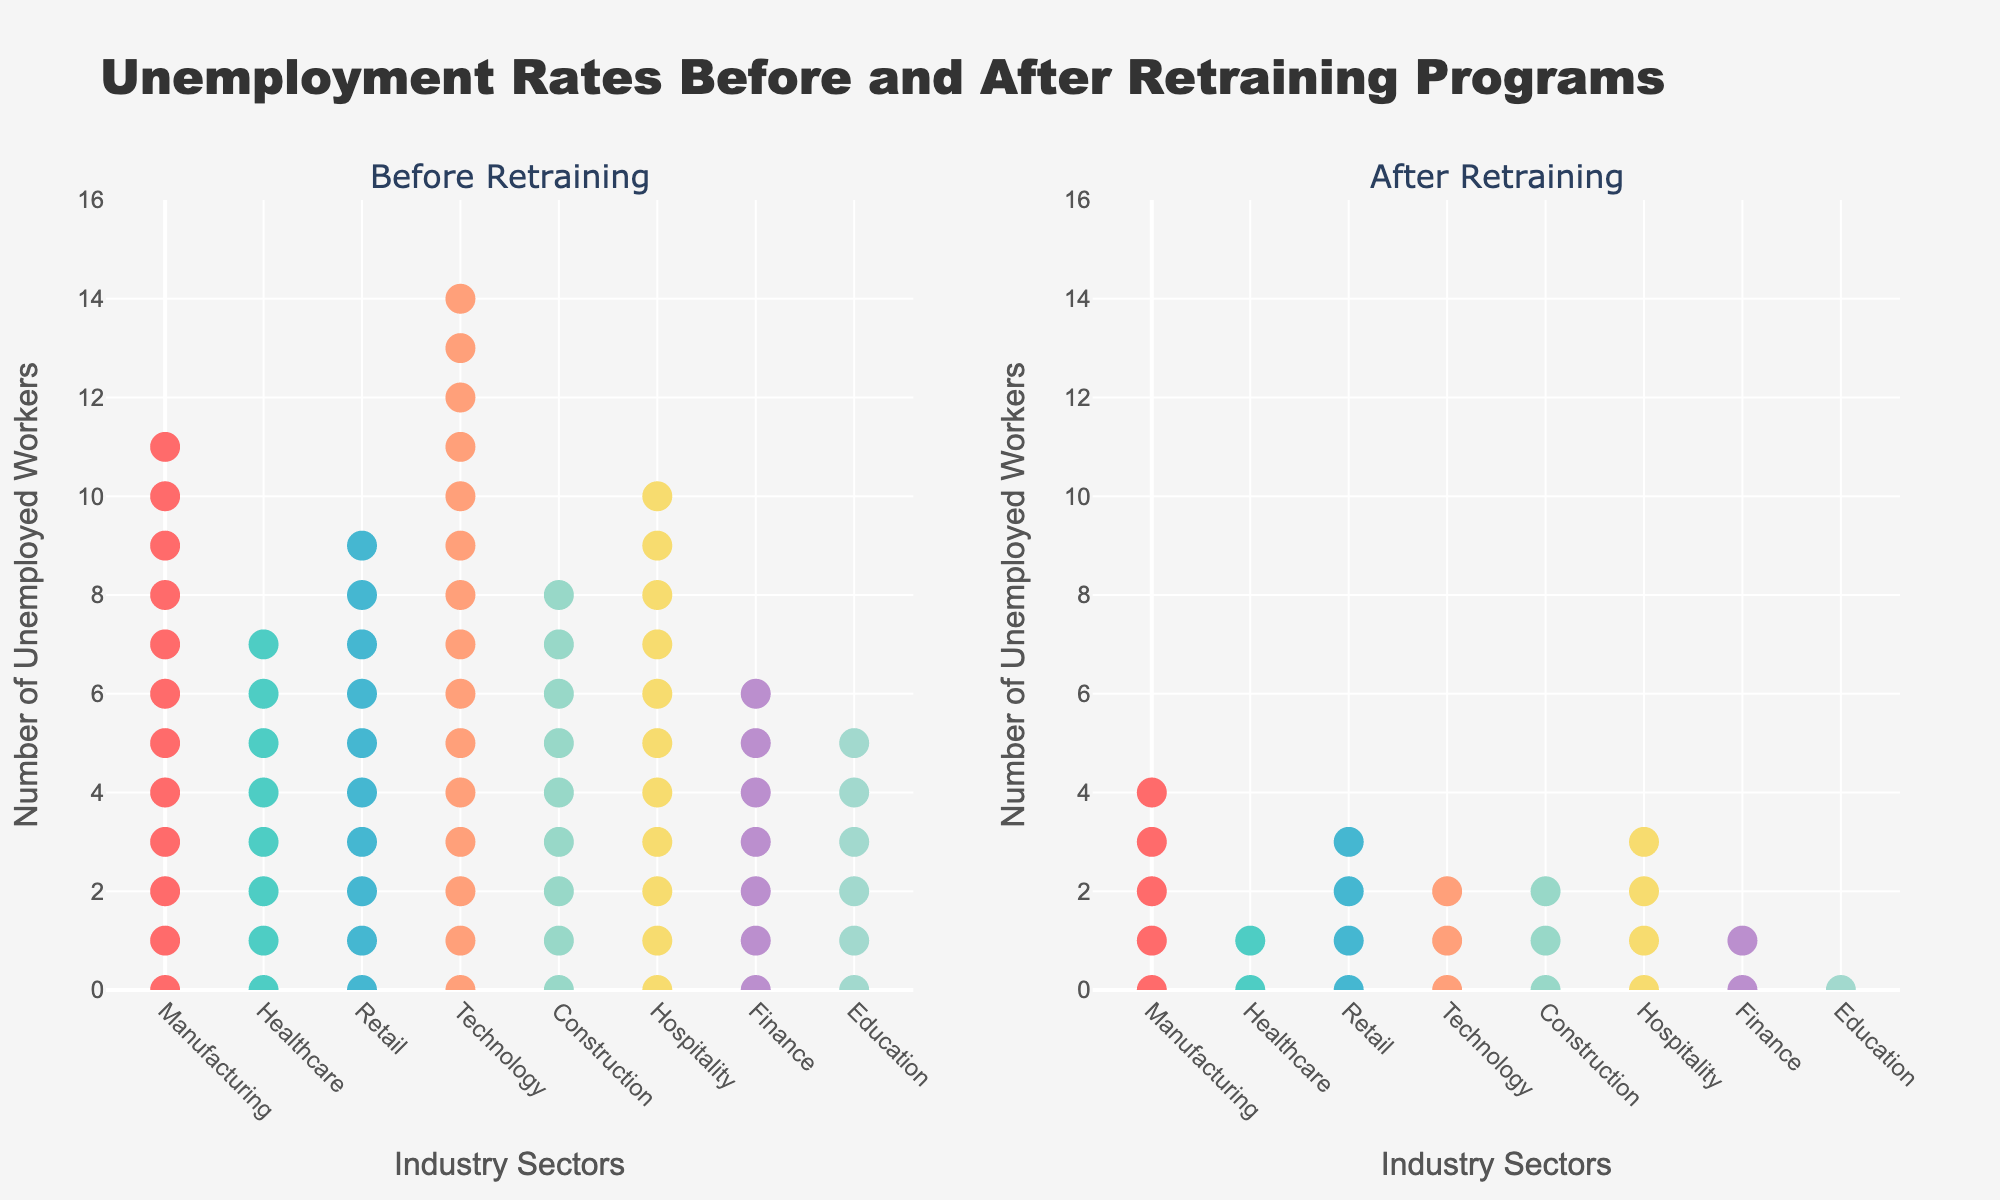What is the title of the figure? The title is prominently placed at the top of the figure. It reads "Unemployment Rates Before and After Retraining Programs".
Answer: Unemployment Rates Before and After Retraining Programs What do the x-axes represent? The x-axes indicate the "Industry Sectors" as described in the axis title below the plot.
Answer: Industry Sectors What do the y-axes represent? The y-axes show the "Number of Unemployed Workers" as mentioned in the axis title beside the plot.
Answer: Number of Unemployed Workers Which industry had the highest unemployment rate before retraining? By examining the number of data points in the "Before Retraining" plot, the Technology sector has the highest number of points, with 15.
Answer: Technology Which industry had the lowest unemployment rate after retraining? The industry with the fewest data points in the "After Retraining" plot is Education, with only 1 point.
Answer: Education By how much did the unemployment rate decrease in the Manufacturing sector? Before retraining, the Manufacturing sector had 12 unemployed workers. After retraining, it had 5 unemployed workers. The difference is 12 - 5 = 7.
Answer: 7 Compare the decline in unemployment rates between the Retail and Hospitality sectors. Which had a greater decline? The Retail sector decreased from 10 to 4 (10 - 4 = 6). The Hospitality sector decreased from 11 to 4 (11 - 4 = 7). The Hospitality sector had a greater decline.
Answer: Hospitality sector How many industry sectors had an unemployment rate of 3 or less after retraining? Checking the data points in the "After Retraining" plot, the Technology, Construction, Healthcare, Finance, and Education sectors all had 3 or fewer unemployed workers. Count: 5.
Answer: 5 What is the overall trend shown in the figure regarding unemployment rates before and after retraining? The trend shows that unemployment rates in all industry sectors decreased after retraining, indicating that the retraining programs were effective across the board.
Answer: Decrease across all sectors 